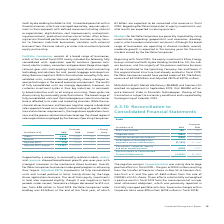According to Siemens Ag's financial document, What was the reason for the increase in the Adjusted EBITDA? Adjusted EBITA improved in all fully consolidated units and turned positive in total, mainly driven by the large drives applications business.. The document states: "ses made good progress in achieving their targets. Adjusted EBITA improved in all fully consolidated units and turned positive in total, mainly driven..." Also, How have the markets for Portfolio Companies been impacted? Based on the financial document, the answer is Markets for Portfolio Companies are generally impacted by rising uncertainties regarding geopolitical and economic developments, which weaken investment sentiment.. Also, If the new organizational structure had already existed in fiscal 2019, Smart Infrastructure would have posted what revenue in 2019?  According to the financial document, 4.558 billion. The relevant text states: "ve posted orders of € 4.746 billion, revenue of € 4.558 billion and Adjusted EBITA of €(115) million...." Also, can you calculate: What was the average orders for 2019 and 2018? To answer this question, I need to perform calculations using the financial data. The calculation is: (5,806 + 5,569) / 2, which equals 5687.5 (in millions). This is based on the information: "Orders 5,806 5,569 4 % 3 % Orders 5,806 5,569 4 % 3 %..." The key data points involved are: 5,569, 5,806. Also, can you calculate: What is the increase / (decrease) in revenue from 2018 to 2019? Based on the calculation: 5,526 - 4,930, the result is 596 (in millions). This is based on the information: "Revenue 5,526 4,930 12 % 11 % Revenue 5,526 4,930 12 % 11 %..." The key data points involved are: 4,930, 5,526. Also, can you calculate: What is the increase / (decrease) in the Adjusted EBITDA margin from 2018 to 2019? Based on the calculation: (1.3%) - (6.2%), the result is -4.9 (percentage). This is based on the information: "Adjusted EBITA margin (1.3) % (6.2) % Adjusted EBITA margin (1.3) % (6.2) %..." The key data points involved are: 1.3, 6.2. 